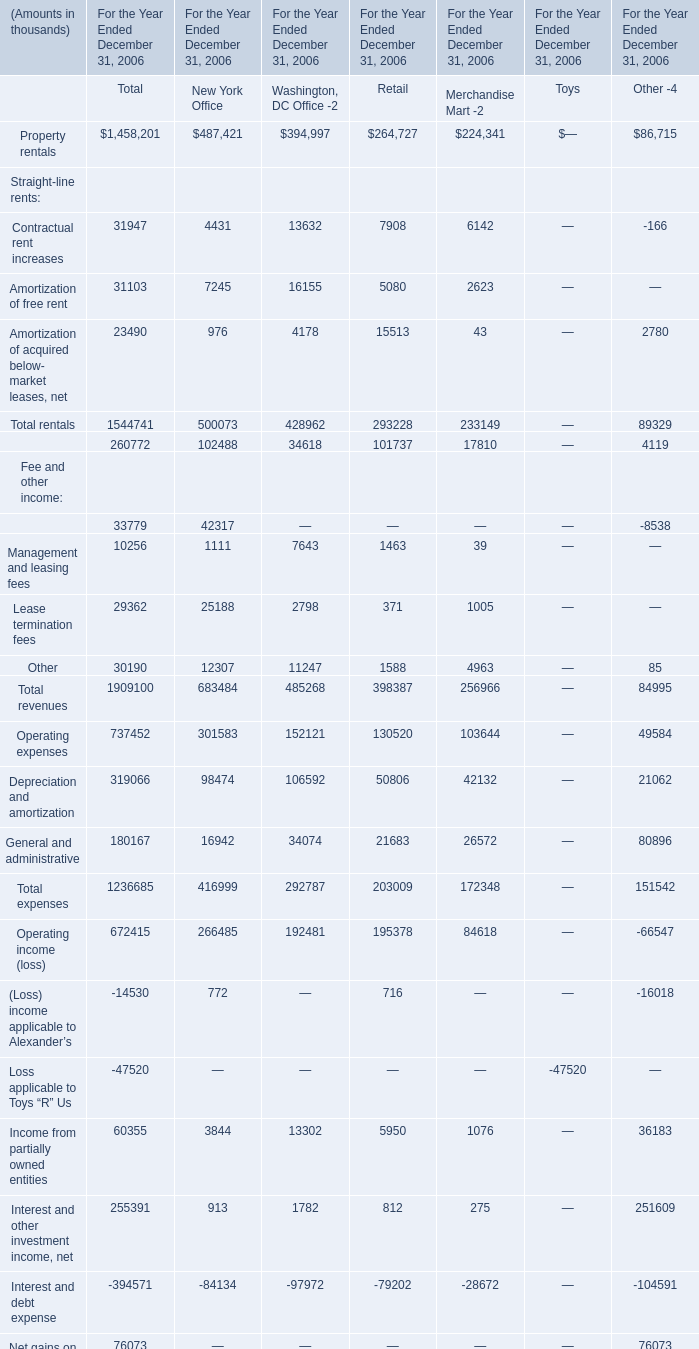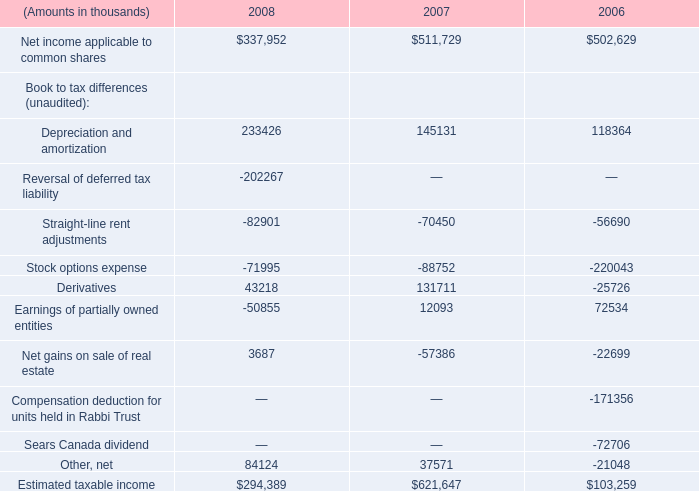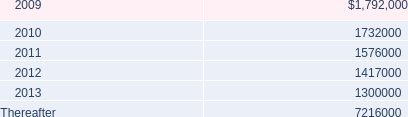What was the average value of the (Loss) income applicable to Alexander’s in the years whereProperty rentals is positive? (in thousand) 
Computations: (-14530 / 1)
Answer: -14530.0. 